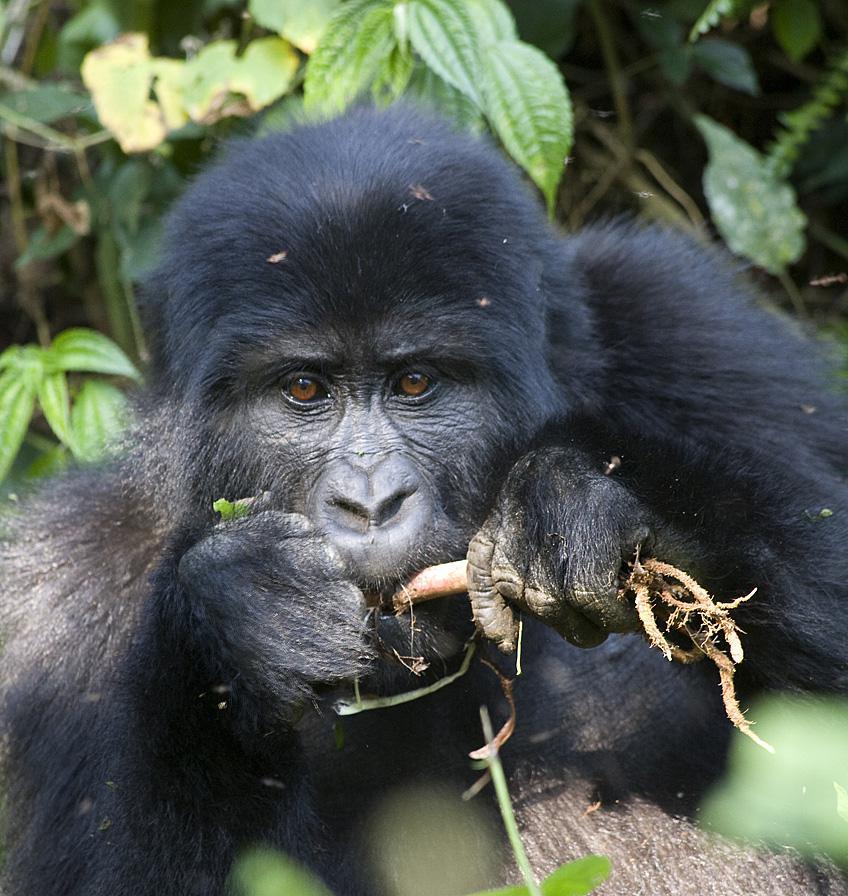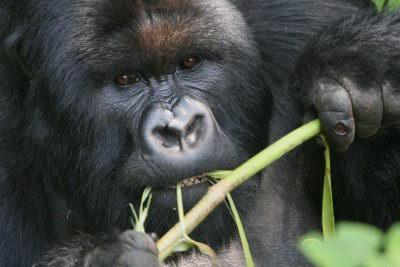The first image is the image on the left, the second image is the image on the right. Evaluate the accuracy of this statement regarding the images: "Only the image on the right depicts a gorilla holding food up to its mouth.". Is it true? Answer yes or no. No. The first image is the image on the left, the second image is the image on the right. Considering the images on both sides, is "Each image shows a gorilla grasping edible plant material, and at least one image shows a gorilla chewing on the item." valid? Answer yes or no. Yes. 